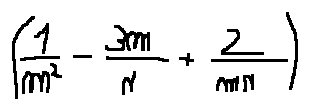<formula> <loc_0><loc_0><loc_500><loc_500>( \frac { 1 } { m ^ { 2 } } - \frac { 3 m } { n } + \frac { 2 } { m n } )</formula> 